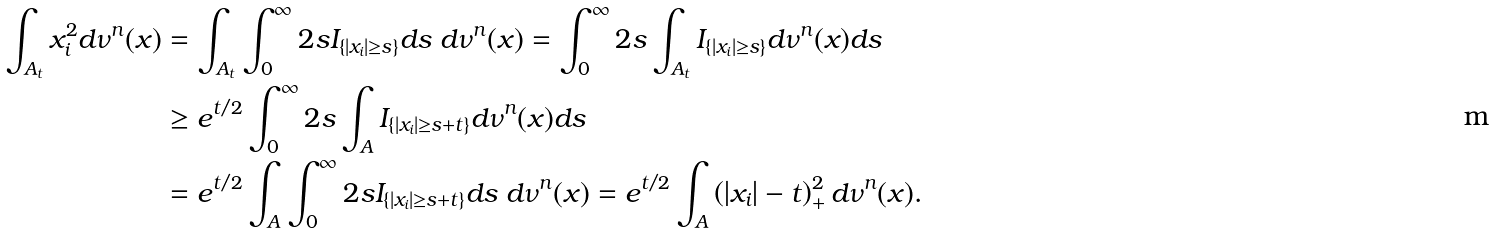Convert formula to latex. <formula><loc_0><loc_0><loc_500><loc_500>\int _ { A _ { t } } x _ { i } ^ { 2 } d \nu ^ { n } ( x ) & = \int _ { A _ { t } } \int _ { 0 } ^ { \infty } 2 s I _ { \{ | x _ { i } | \geq s \} } d s \ d \nu ^ { n } ( x ) = \int _ { 0 } ^ { \infty } 2 s \int _ { A _ { t } } I _ { \{ | x _ { i } | \geq s \} } d \nu ^ { n } ( x ) d s \\ & \geq e ^ { t / 2 } \int _ { 0 } ^ { \infty } 2 s \int _ { A } I _ { \{ | x _ { i } | \geq s + t \} } d \nu ^ { n } ( x ) d s \\ & = e ^ { t / 2 } \int _ { A } \int _ { 0 } ^ { \infty } 2 s I _ { \{ | x _ { i } | \geq s + t \} } d s \ d \nu ^ { n } ( x ) = e ^ { t / 2 } \int _ { A } \left ( | x _ { i } | - t \right ) _ { + } ^ { 2 } d \nu ^ { n } ( x ) .</formula> 